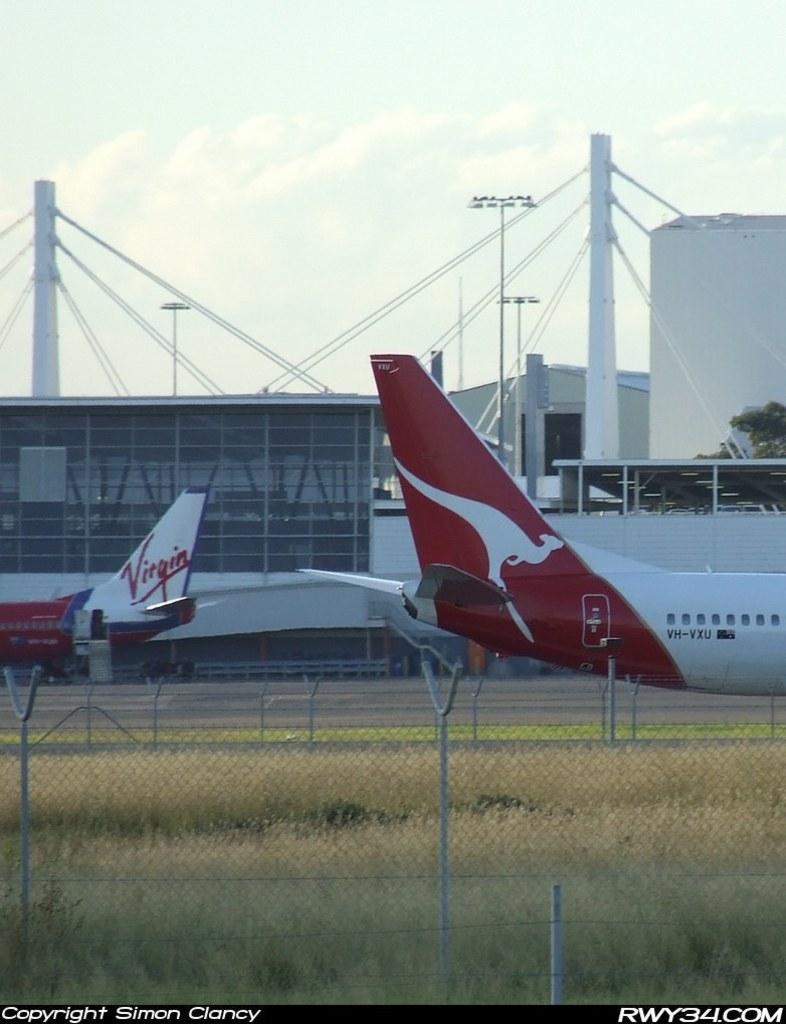Who is this copyrighted by?
Keep it short and to the point. Simon clancy. What brand is on the plane?
Give a very brief answer. Virgin. 